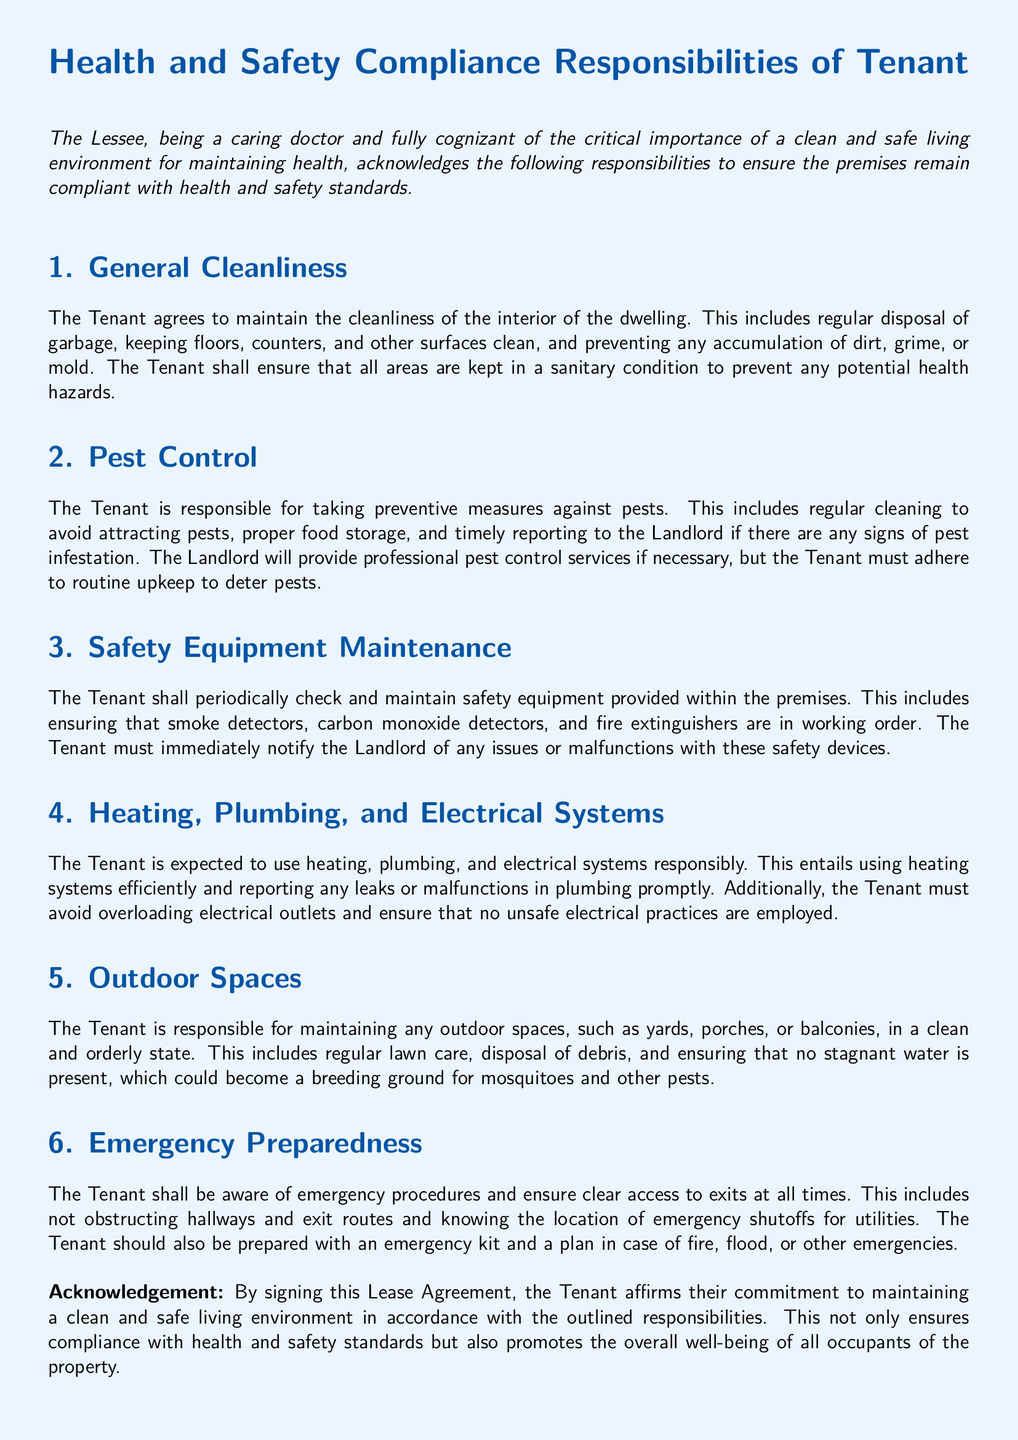What responsibilities does the Tenant have regarding cleanliness? The responsibilities include regular disposal of garbage and keeping surfaces clean to prevent dirt, grime, or mold.
Answer: Cleanliness of the interior, regular garbage disposal, clean surfaces What should the Tenant do if they notice a pest infestation? The Tenant must timely report any signs of pest infestation to the Landlord.
Answer: Report to the Landlord What safety equipment is the Tenant responsible for maintaining? The Tenant is responsible for maintaining smoke detectors, carbon monoxide detectors, and fire extinguishers.
Answer: Smoke detectors, carbon monoxide detectors, fire extinguishers What does the Tenant need to ensure about emergency exits? The Tenant must ensure clear access to exits at all times and not obstruct hallways and exit routes.
Answer: Clear access to exits How often should the Tenant check safety equipment? The Tenant should periodically check safety equipment as per the agreement.
Answer: Periodically What is the Tenant's obligation regarding outdoor spaces? The Tenant must maintain outdoor spaces such as yards, porches, or balconies in a clean state.
Answer: Maintain outdoor spaces clean What must the Tenant do if there are leaks in the plumbing? The Tenant must report any leaks or malfunctions in plumbing promptly.
Answer: Report promptly What is emphasized as critical for maintaining health in the living environment? Maintaining a clean and safe living environment is critical for health.
Answer: Clean and safe living environment 